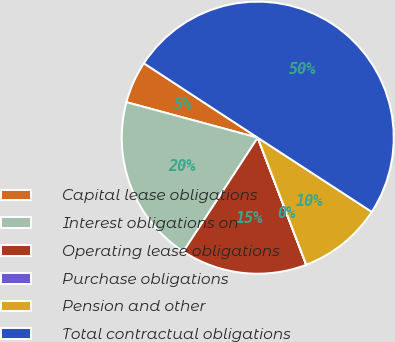<chart> <loc_0><loc_0><loc_500><loc_500><pie_chart><fcel>Capital lease obligations<fcel>Interest obligations on<fcel>Operating lease obligations<fcel>Purchase obligations<fcel>Pension and other<fcel>Total contractual obligations<nl><fcel>5.01%<fcel>20.0%<fcel>15.0%<fcel>0.02%<fcel>10.01%<fcel>49.97%<nl></chart> 